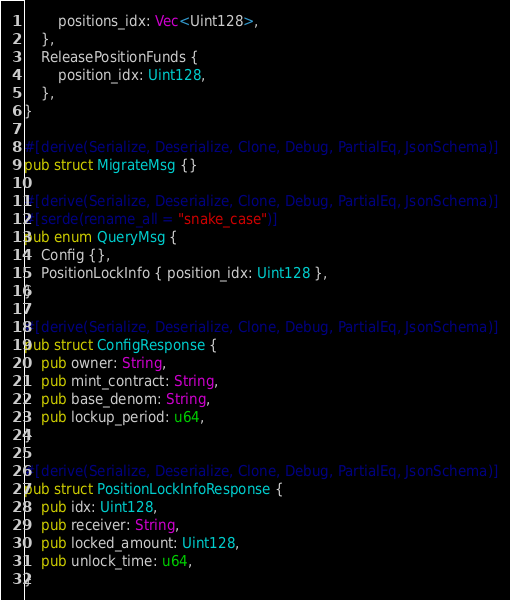<code> <loc_0><loc_0><loc_500><loc_500><_Rust_>        positions_idx: Vec<Uint128>,
    },
    ReleasePositionFunds {
        position_idx: Uint128,
    },
}

#[derive(Serialize, Deserialize, Clone, Debug, PartialEq, JsonSchema)]
pub struct MigrateMsg {}

#[derive(Serialize, Deserialize, Clone, Debug, PartialEq, JsonSchema)]
#[serde(rename_all = "snake_case")]
pub enum QueryMsg {
    Config {},
    PositionLockInfo { position_idx: Uint128 },
}

#[derive(Serialize, Deserialize, Clone, Debug, PartialEq, JsonSchema)]
pub struct ConfigResponse {
    pub owner: String,
    pub mint_contract: String,
    pub base_denom: String,
    pub lockup_period: u64,
}

#[derive(Serialize, Deserialize, Clone, Debug, PartialEq, JsonSchema)]
pub struct PositionLockInfoResponse {
    pub idx: Uint128,
    pub receiver: String,
    pub locked_amount: Uint128,
    pub unlock_time: u64,
}
</code> 